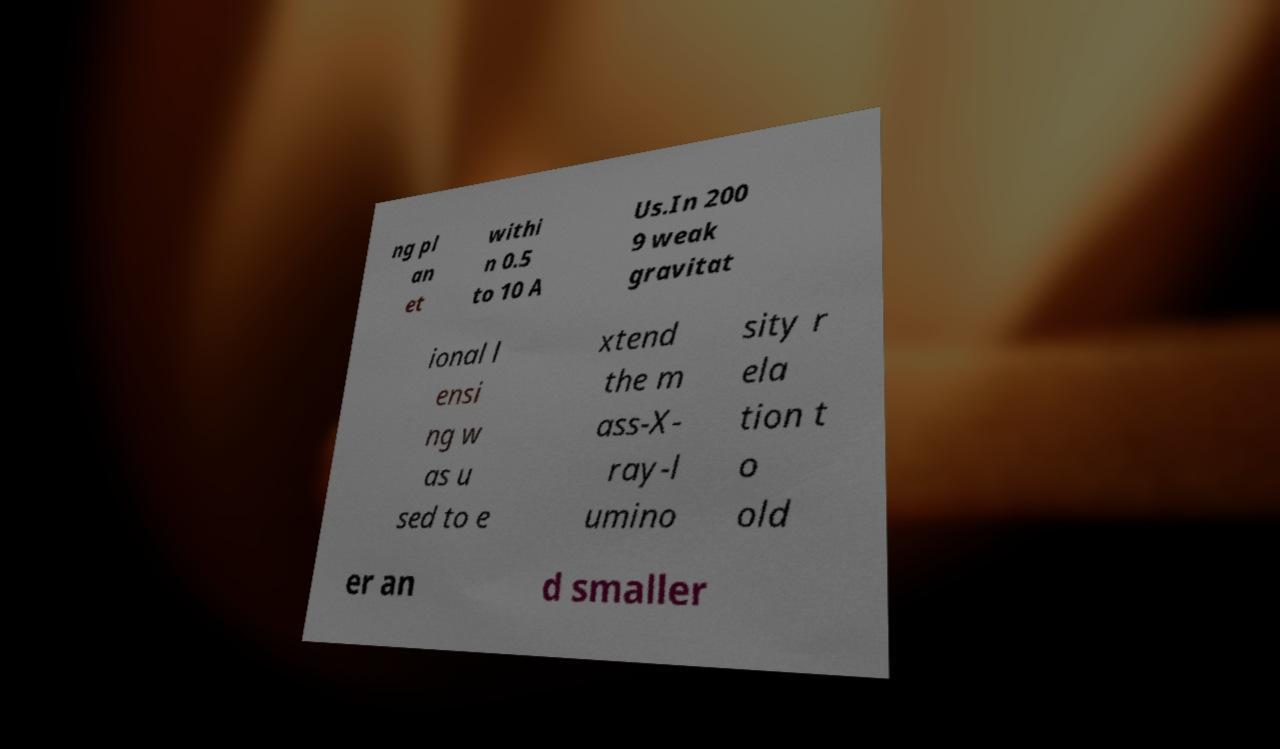Can you accurately transcribe the text from the provided image for me? ng pl an et withi n 0.5 to 10 A Us.In 200 9 weak gravitat ional l ensi ng w as u sed to e xtend the m ass-X- ray-l umino sity r ela tion t o old er an d smaller 